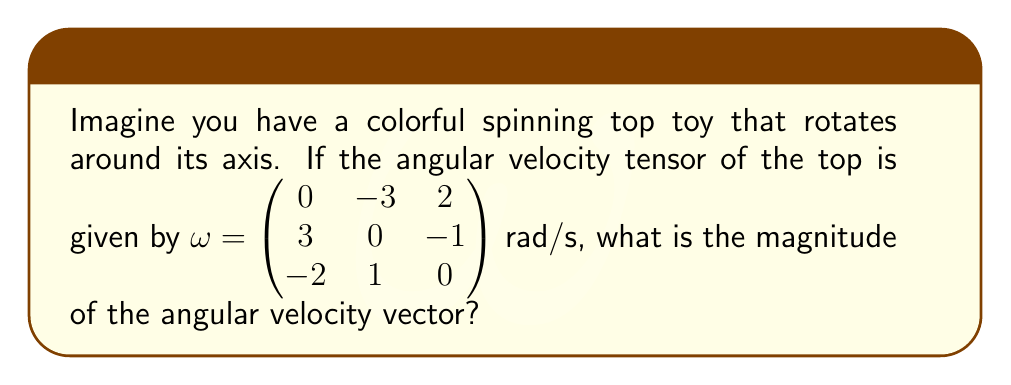Provide a solution to this math problem. Let's break this down into simple steps:

1) The angular velocity tensor $\omega$ is a skew-symmetric matrix that represents the rotation of the spinning top. We can extract the angular velocity vector from this tensor.

2) The angular velocity vector $\vec{\omega}$ is related to the tensor as follows:
   $$\vec{\omega} = (-\omega_{23}, \omega_{13}, -\omega_{12})$$

3) From the given tensor, we can identify:
   $\omega_{23} = 2$, $\omega_{13} = 3$, $\omega_{12} = 3$

4) Therefore, the angular velocity vector is:
   $$\vec{\omega} = (-2, 3, -3)$$

5) To find the magnitude of this vector, we use the formula:
   $$|\vec{\omega}| = \sqrt{\omega_x^2 + \omega_y^2 + \omega_z^2}$$

6) Substituting the values:
   $$|\vec{\omega}| = \sqrt{(-2)^2 + 3^2 + (-3)^2}$$

7) Simplifying:
   $$|\vec{\omega}| = \sqrt{4 + 9 + 9} = \sqrt{22}$$

8) The square root of 22 cannot be simplified further, so this is our final answer.
Answer: $\sqrt{22}$ rad/s 